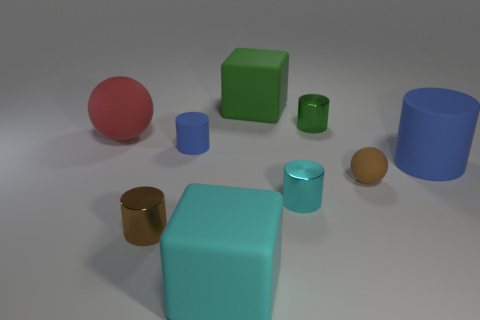Subtract all cyan cylinders. How many cylinders are left? 4 Subtract 2 cylinders. How many cylinders are left? 3 Subtract all tiny brown metal cylinders. How many cylinders are left? 4 Subtract all yellow cylinders. Subtract all purple blocks. How many cylinders are left? 5 Add 1 rubber spheres. How many objects exist? 10 Subtract all balls. How many objects are left? 7 Add 9 green cylinders. How many green cylinders are left? 10 Add 6 large green matte cubes. How many large green matte cubes exist? 7 Subtract 1 green cylinders. How many objects are left? 8 Subtract all large blue cylinders. Subtract all green shiny things. How many objects are left? 7 